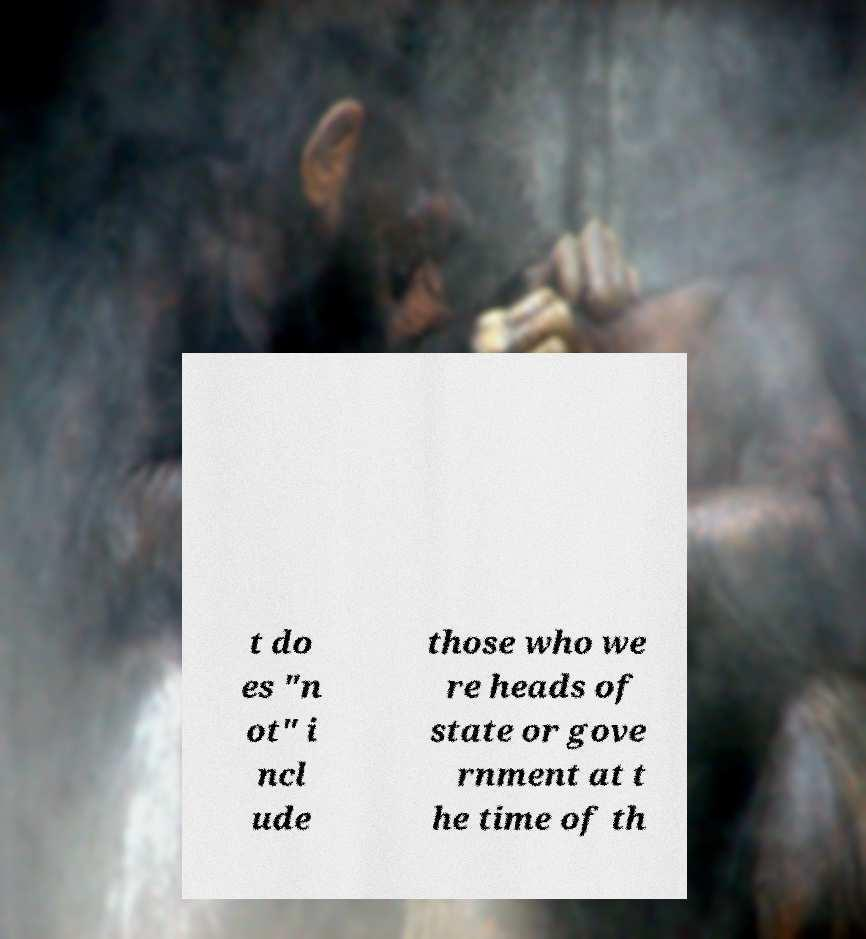For documentation purposes, I need the text within this image transcribed. Could you provide that? t do es "n ot" i ncl ude those who we re heads of state or gove rnment at t he time of th 